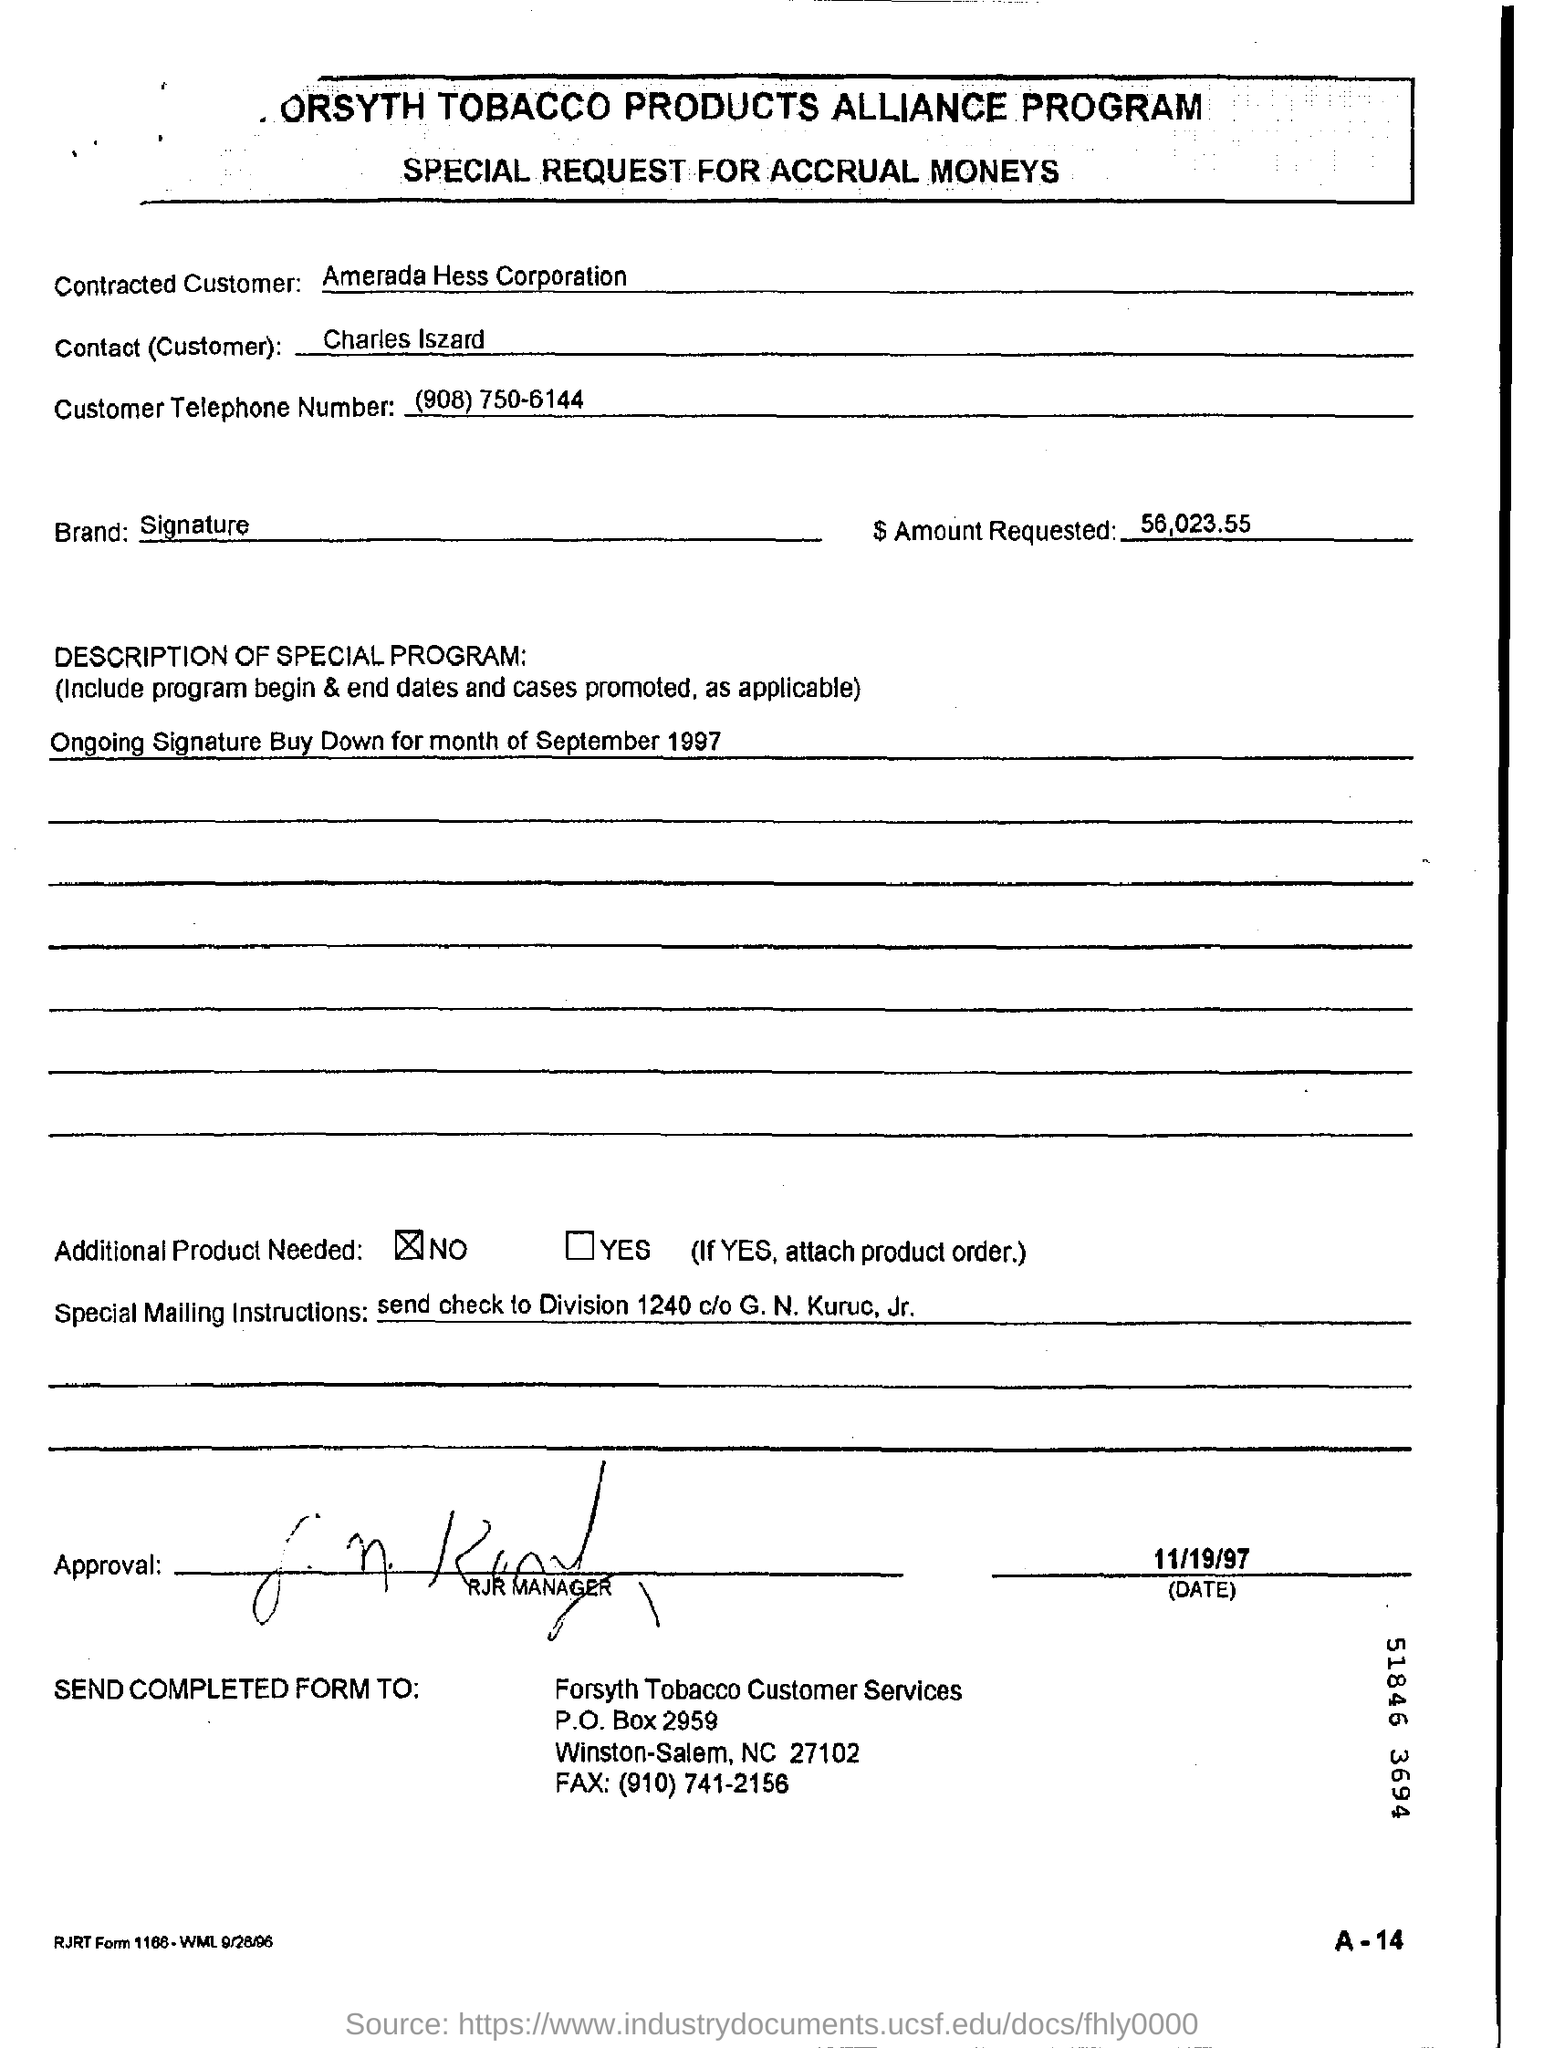What is the $ Amount Requested?
Offer a terse response. 56,023.55. What is the Brand?
Make the answer very short. Signature. Who is the Contracted Customer?
Provide a succinct answer. Amerada Hess Corporation. What is the Customer Telephone Number?
Your response must be concise. (908) 750-6144. What is the date on the document?
Offer a terse response. 11/19/97. 